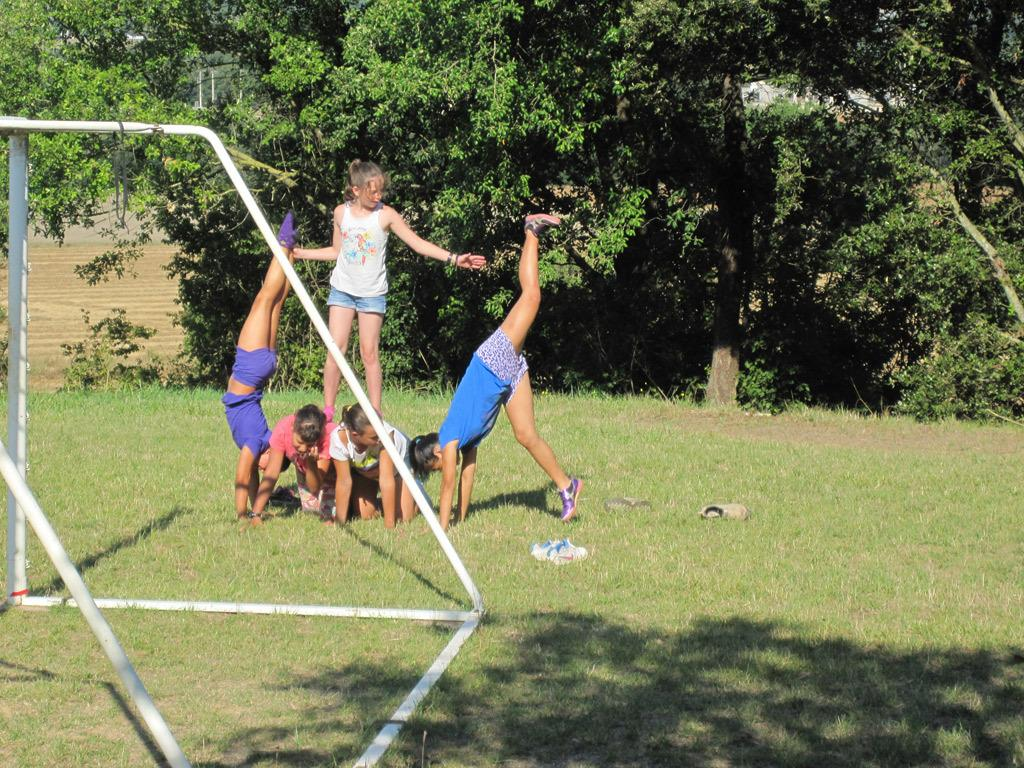What are the people in the image doing? The people in the image are playing on the ground. What else can be seen on the ground besides the people? There are objects on the ground. What type of structures are present in the image? There are iron poles in the image. What type of vegetation can be seen in the image? There are trees, bushes, and plants in the image. What is the ground covered with? There is grass on the ground. What type of oven can be seen in the image? There is no oven present in the image. 